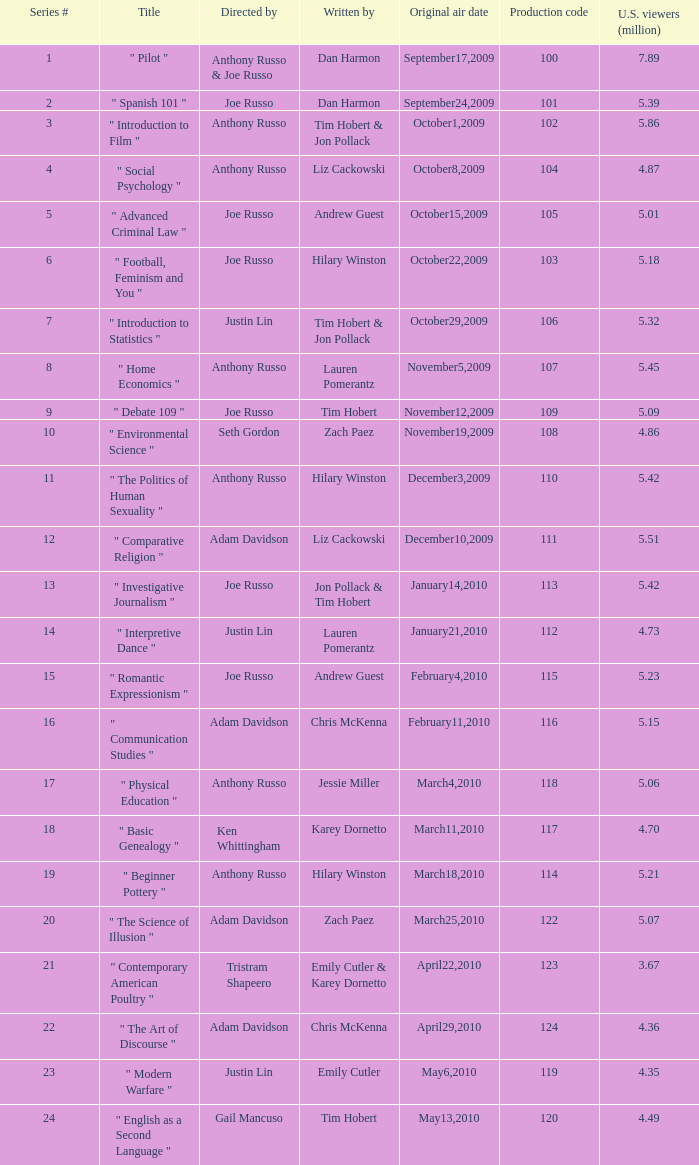What is the title of the series # 8? " Home Economics ". 